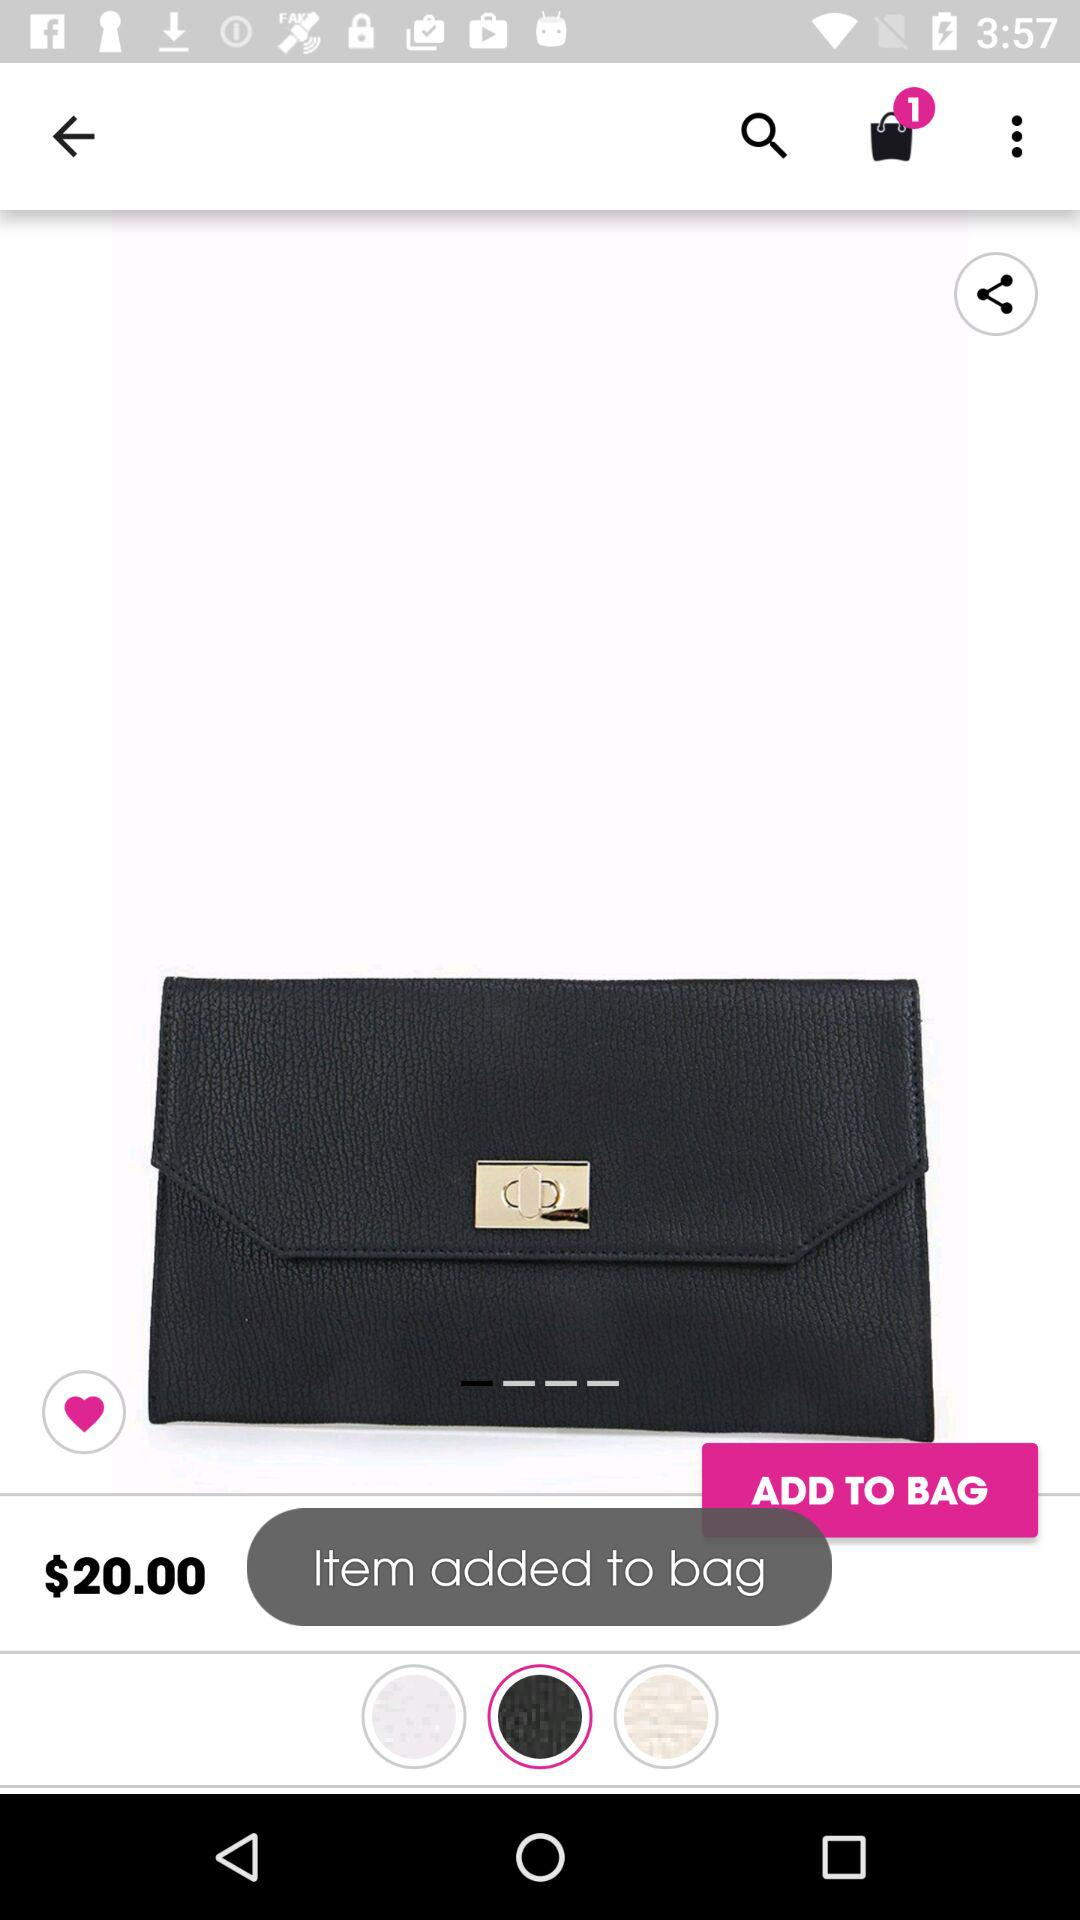How many items are in the shopping bag?
Answer the question using a single word or phrase. 1 